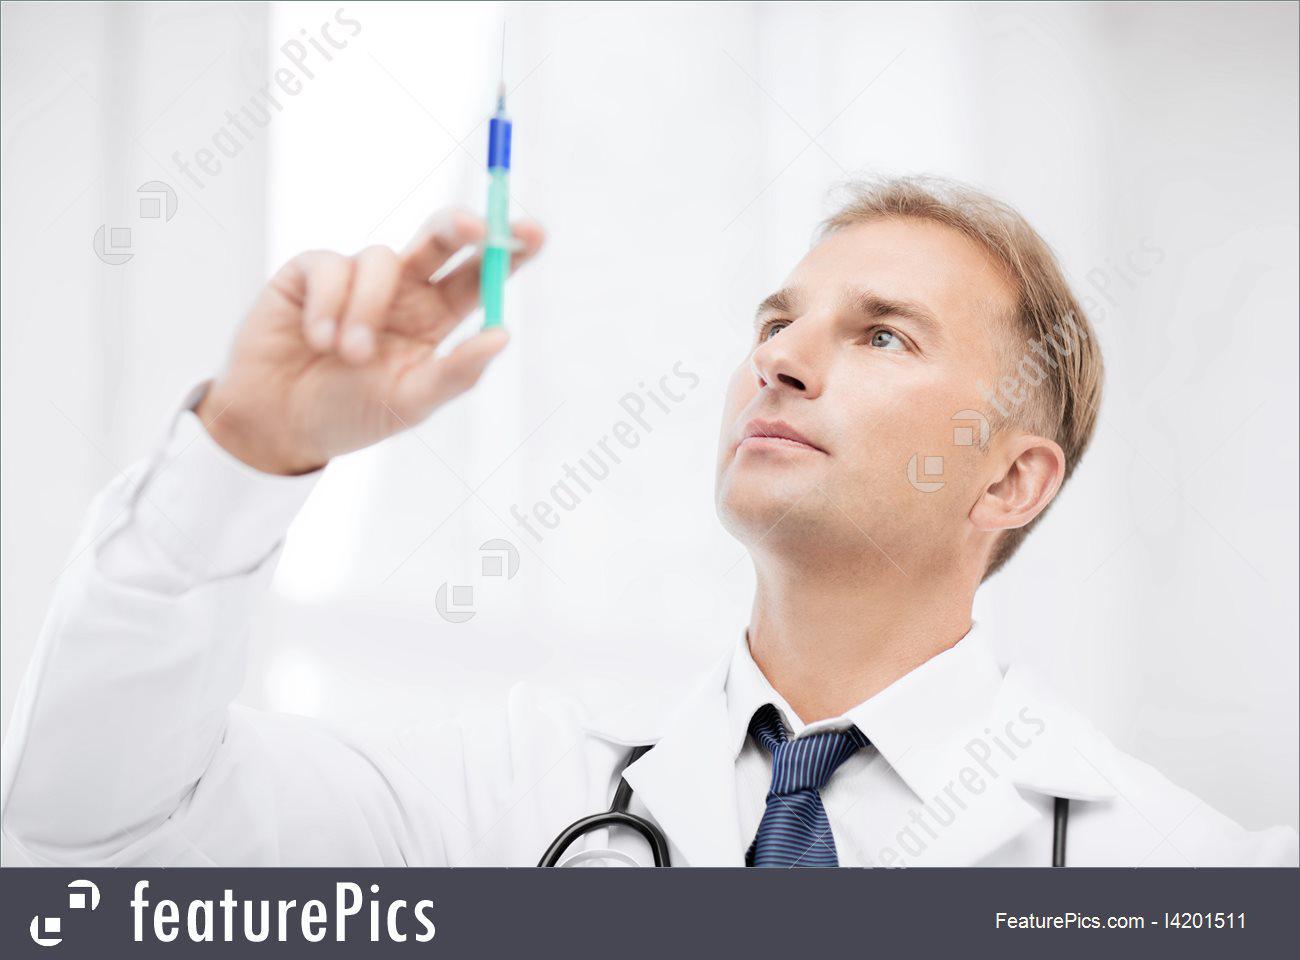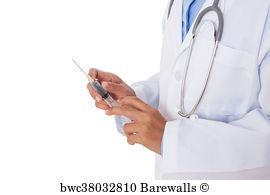The first image is the image on the left, the second image is the image on the right. Assess this claim about the two images: "In at least one of the images, a medical professional is looking directly at a syringe full of blue liquid.". Correct or not? Answer yes or no. Yes. The first image is the image on the left, the second image is the image on the right. For the images shown, is this caption "The left image shows a man holding up an aqua-colored syringe with one bare hand." true? Answer yes or no. Yes. 